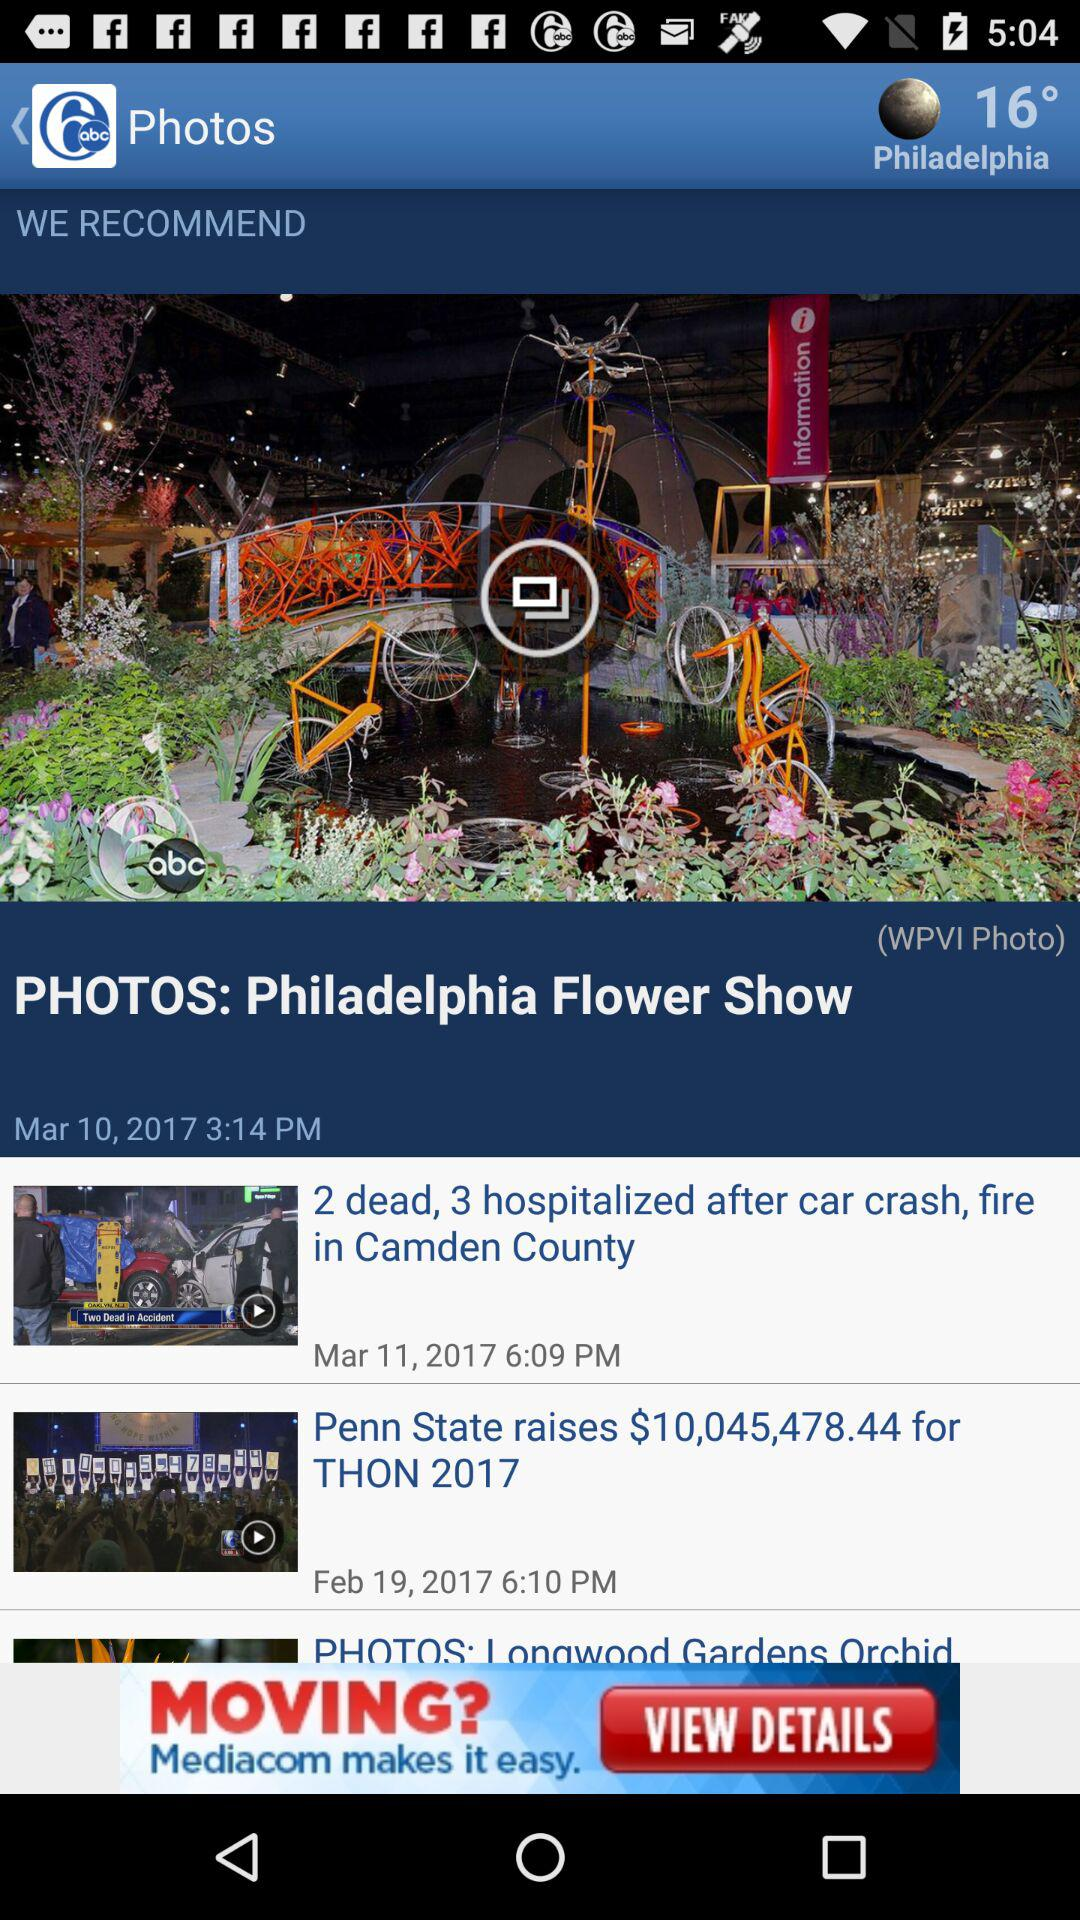On March 11, what video was posted? The video posted on March 11 was "2 dead, 3 hospitalized after car crash, fire in Camden County". 